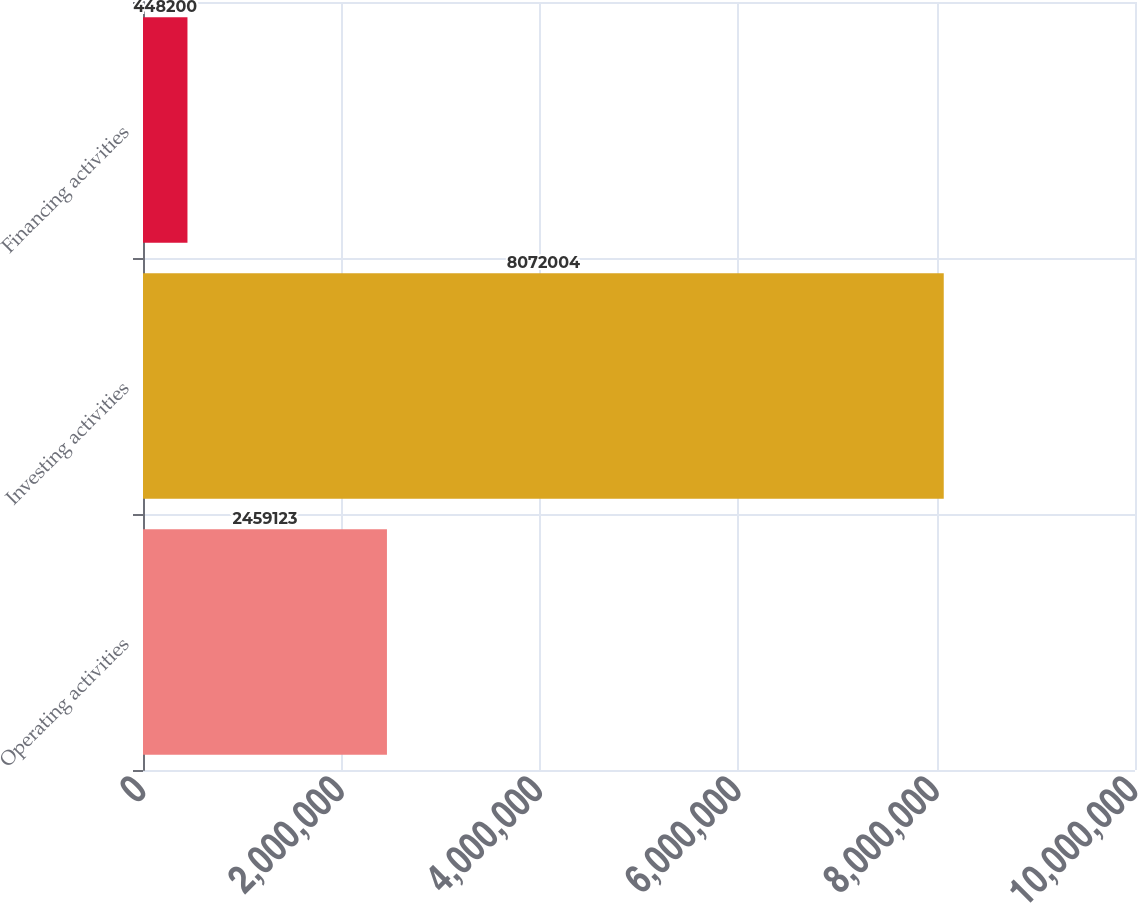Convert chart to OTSL. <chart><loc_0><loc_0><loc_500><loc_500><bar_chart><fcel>Operating activities<fcel>Investing activities<fcel>Financing activities<nl><fcel>2.45912e+06<fcel>8.072e+06<fcel>448200<nl></chart> 